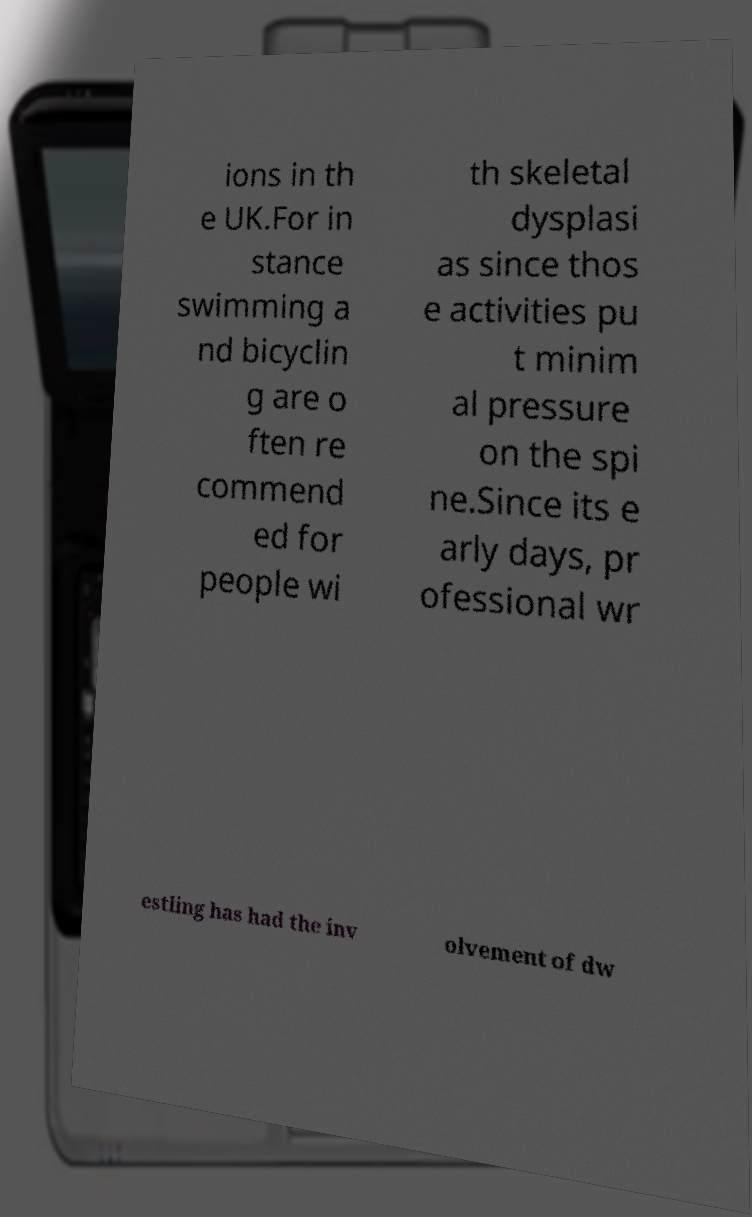I need the written content from this picture converted into text. Can you do that? ions in th e UK.For in stance swimming a nd bicyclin g are o ften re commend ed for people wi th skeletal dysplasi as since thos e activities pu t minim al pressure on the spi ne.Since its e arly days, pr ofessional wr estling has had the inv olvement of dw 